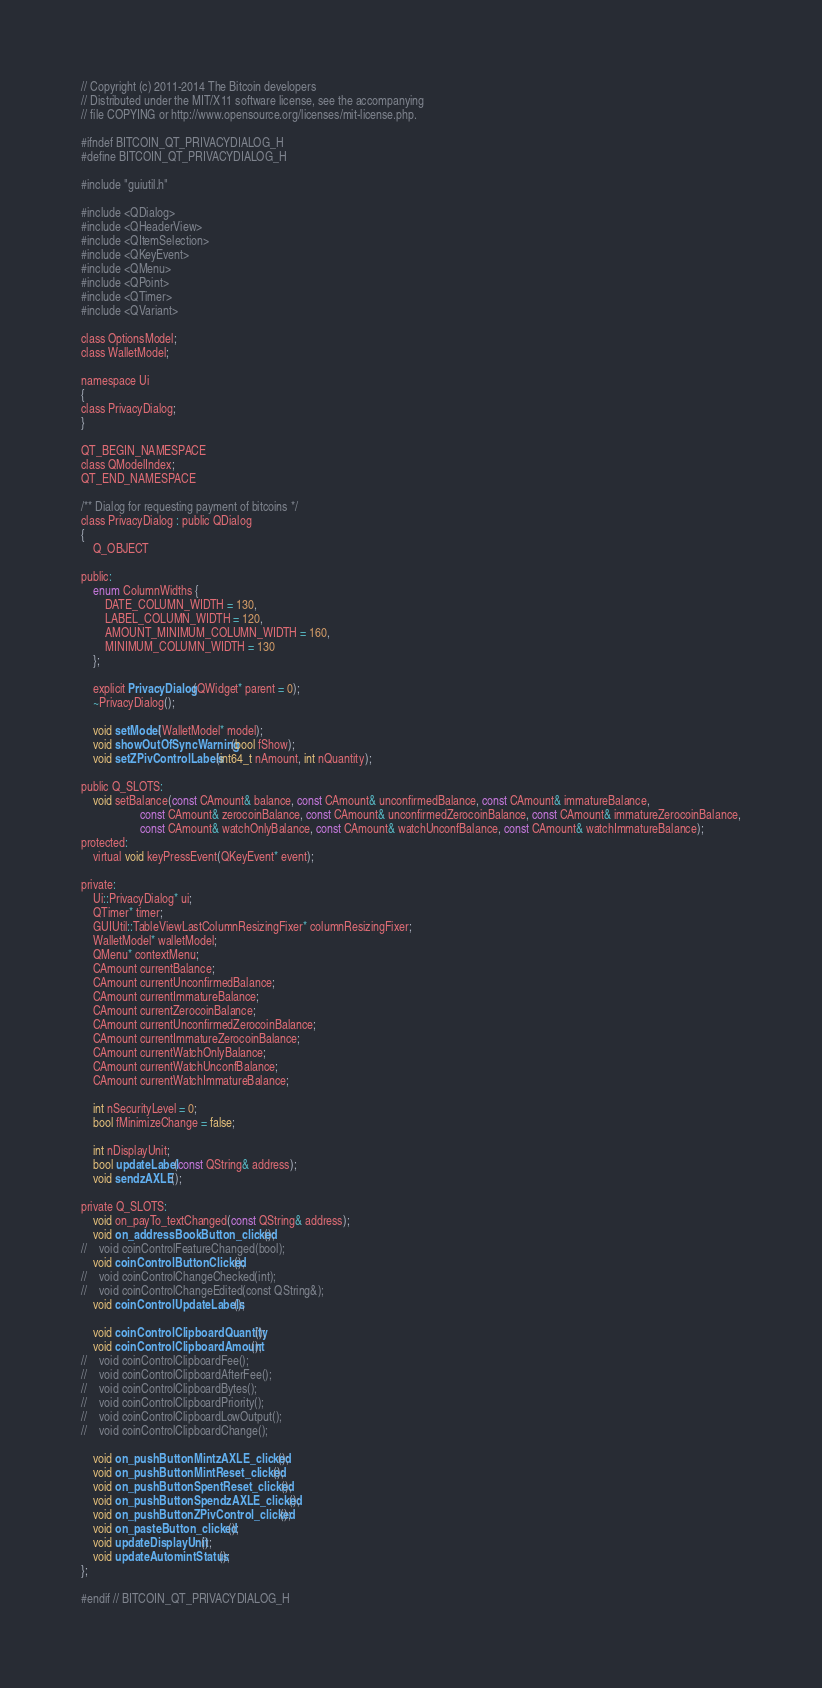<code> <loc_0><loc_0><loc_500><loc_500><_C_>// Copyright (c) 2011-2014 The Bitcoin developers
// Distributed under the MIT/X11 software license, see the accompanying
// file COPYING or http://www.opensource.org/licenses/mit-license.php.

#ifndef BITCOIN_QT_PRIVACYDIALOG_H
#define BITCOIN_QT_PRIVACYDIALOG_H

#include "guiutil.h"

#include <QDialog>
#include <QHeaderView>
#include <QItemSelection>
#include <QKeyEvent>
#include <QMenu>
#include <QPoint>
#include <QTimer>
#include <QVariant>

class OptionsModel;
class WalletModel;

namespace Ui
{
class PrivacyDialog;
}

QT_BEGIN_NAMESPACE
class QModelIndex;
QT_END_NAMESPACE

/** Dialog for requesting payment of bitcoins */
class PrivacyDialog : public QDialog
{
    Q_OBJECT

public:
    enum ColumnWidths {
        DATE_COLUMN_WIDTH = 130,
        LABEL_COLUMN_WIDTH = 120,
        AMOUNT_MINIMUM_COLUMN_WIDTH = 160,
        MINIMUM_COLUMN_WIDTH = 130
    };

    explicit PrivacyDialog(QWidget* parent = 0);
    ~PrivacyDialog();

    void setModel(WalletModel* model);
    void showOutOfSyncWarning(bool fShow);
    void setZPivControlLabels(int64_t nAmount, int nQuantity);

public Q_SLOTS:
    void setBalance(const CAmount& balance, const CAmount& unconfirmedBalance, const CAmount& immatureBalance, 
                    const CAmount& zerocoinBalance, const CAmount& unconfirmedZerocoinBalance, const CAmount& immatureZerocoinBalance,
                    const CAmount& watchOnlyBalance, const CAmount& watchUnconfBalance, const CAmount& watchImmatureBalance);
protected:
    virtual void keyPressEvent(QKeyEvent* event);

private:
    Ui::PrivacyDialog* ui;
    QTimer* timer;
    GUIUtil::TableViewLastColumnResizingFixer* columnResizingFixer;
    WalletModel* walletModel;
    QMenu* contextMenu;
    CAmount currentBalance;
    CAmount currentUnconfirmedBalance;
    CAmount currentImmatureBalance;
    CAmount currentZerocoinBalance;
    CAmount currentUnconfirmedZerocoinBalance;
    CAmount currentImmatureZerocoinBalance;
    CAmount currentWatchOnlyBalance;
    CAmount currentWatchUnconfBalance;
    CAmount currentWatchImmatureBalance;
    
    int nSecurityLevel = 0;
    bool fMinimizeChange = false;

    int nDisplayUnit;
    bool updateLabel(const QString& address);
    void sendzAXLE();

private Q_SLOTS:
    void on_payTo_textChanged(const QString& address);
    void on_addressBookButton_clicked();
//    void coinControlFeatureChanged(bool);
    void coinControlButtonClicked();
//    void coinControlChangeChecked(int);
//    void coinControlChangeEdited(const QString&);
    void coinControlUpdateLabels();

    void coinControlClipboardQuantity();
    void coinControlClipboardAmount();
//    void coinControlClipboardFee();
//    void coinControlClipboardAfterFee();
//    void coinControlClipboardBytes();
//    void coinControlClipboardPriority();
//    void coinControlClipboardLowOutput();
//    void coinControlClipboardChange();

    void on_pushButtonMintzAXLE_clicked();
    void on_pushButtonMintReset_clicked();
    void on_pushButtonSpentReset_clicked();
    void on_pushButtonSpendzAXLE_clicked();
    void on_pushButtonZPivControl_clicked();
    void on_pasteButton_clicked();
    void updateDisplayUnit();
    void updateAutomintStatus();
};

#endif // BITCOIN_QT_PRIVACYDIALOG_H
</code> 